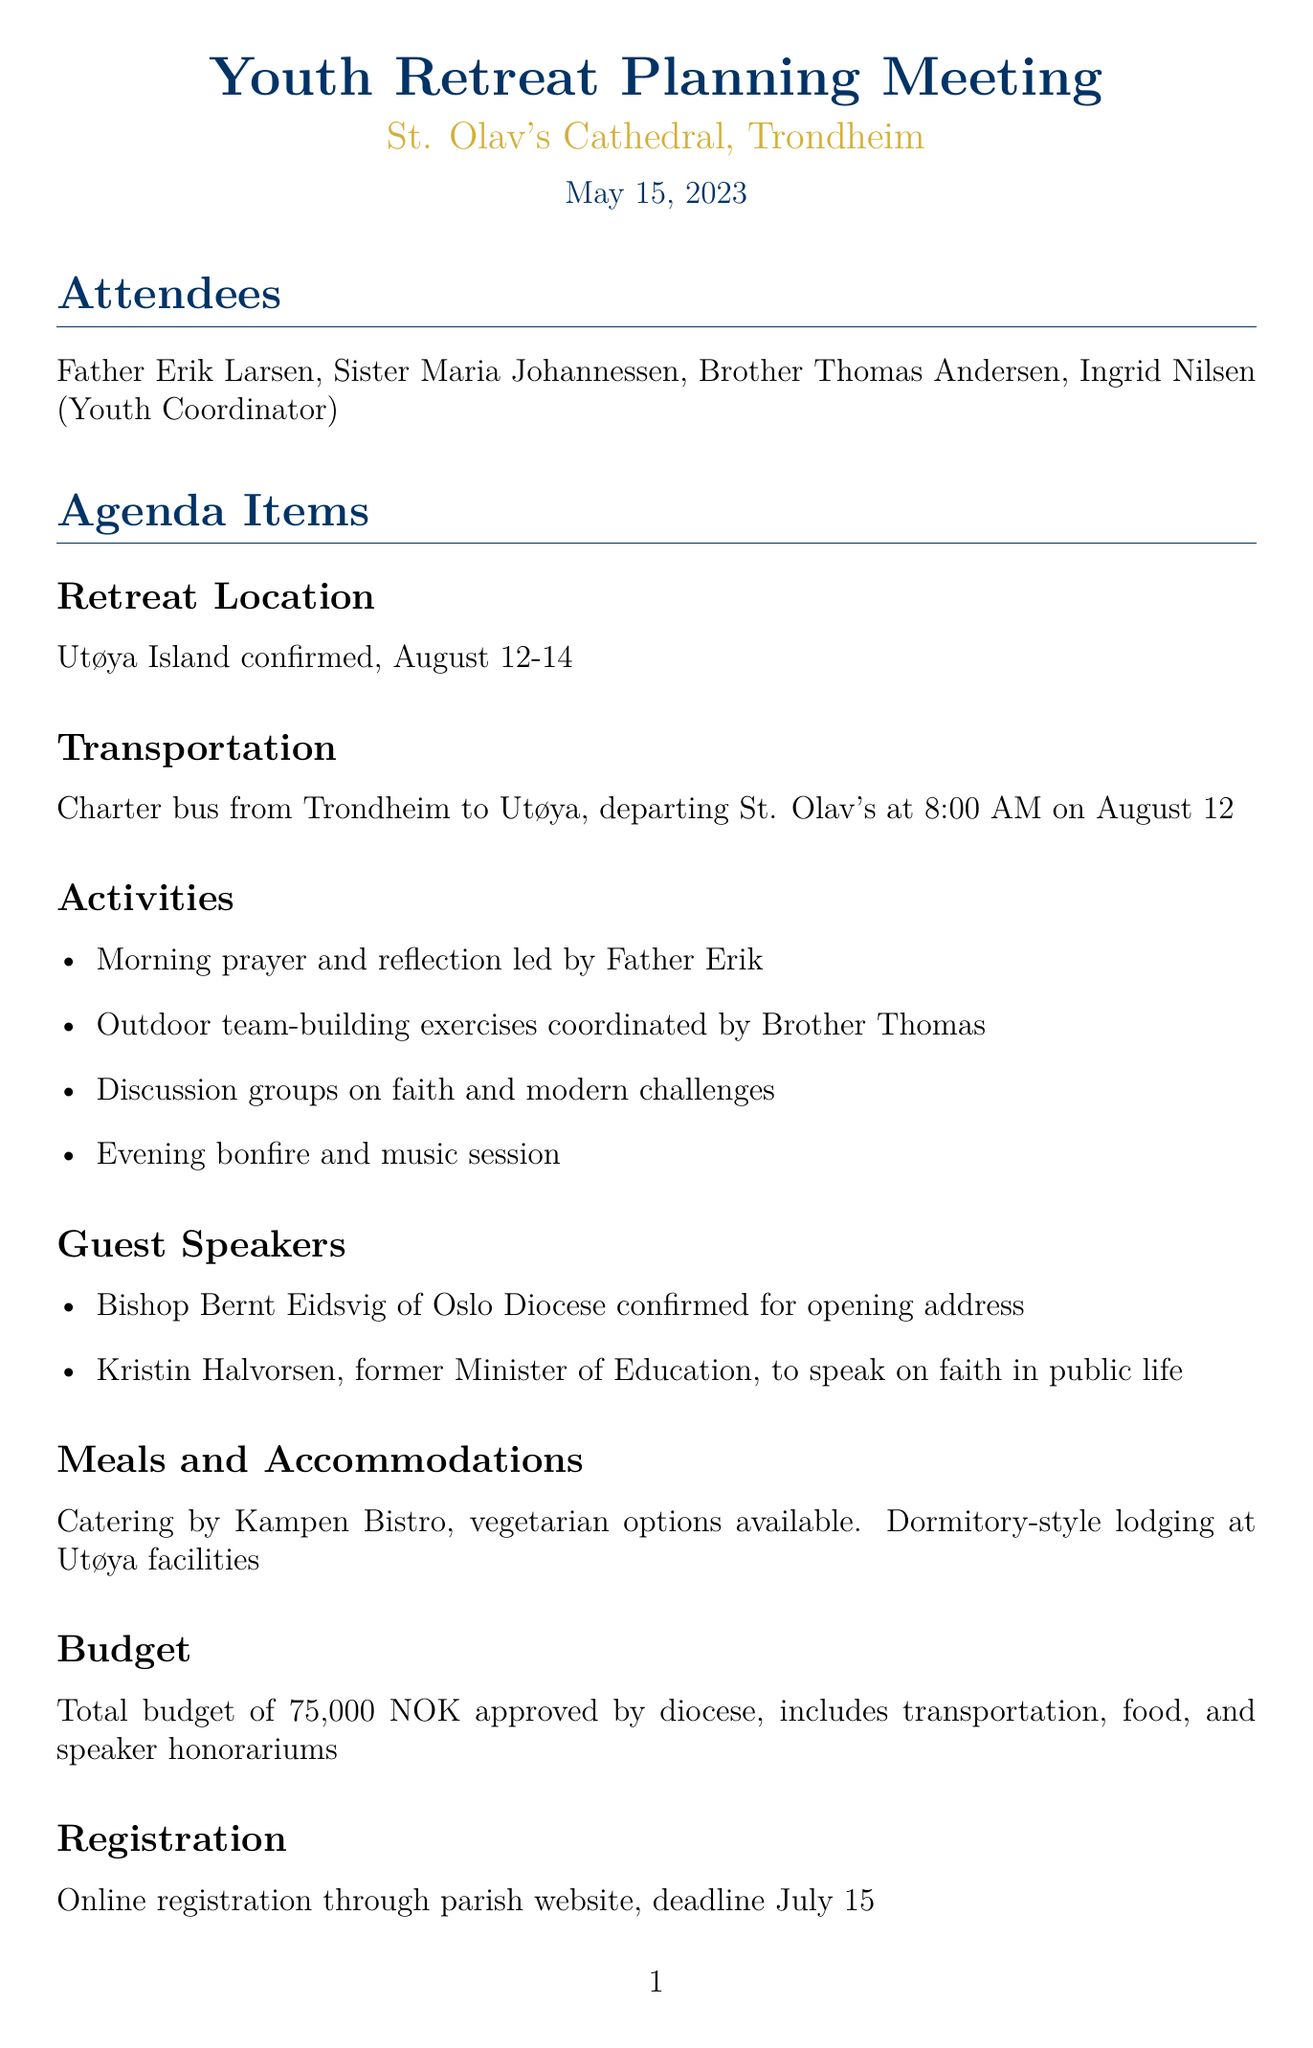what is the date of the meeting? The date of the meeting is explicitly mentioned in the document as May 15, 2023.
Answer: May 15, 2023 where is the retreat being held? The location of the retreat is provided in the agenda and is Utøya Island.
Answer: Utøya Island what time does the charter bus depart? The departure time for the charter bus is stated in the transportation section as 8:00 AM.
Answer: 8:00 AM who is confirmed for the opening address? The document specifies Bishop Bernt Eidsvig as the confirmed speaker for the opening address.
Answer: Bishop Bernt Eidsvig what is the total budget for the retreat? The budget section mentions the total budget approved is 75,000 NOK.
Answer: 75,000 NOK what kind of lodging will be provided? The meals and accommodations section specifies that lodging will be dormitory-style at Utøya facilities.
Answer: Dormitory-style who is responsible for finalizing the activity schedule? The action items state that Ingrid is tasked with finalizing the activity schedule by June 1.
Answer: Ingrid what is the registration deadline? The registration section clearly indicates the deadline as July 15.
Answer: July 15 how many days is the retreat scheduled to last? The retreat location section indicates that the retreat is scheduled for August 12-14, which is two days.
Answer: two days 